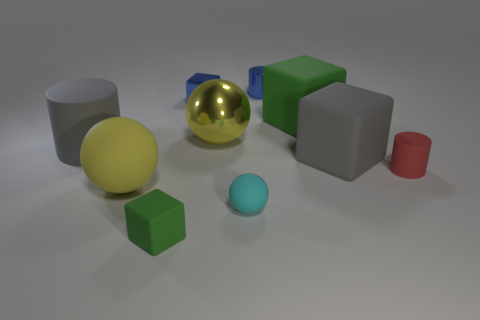How many yellow balls must be subtracted to get 1 yellow balls? 1 Subtract all tiny rubber blocks. How many blocks are left? 3 Subtract all brown cylinders. How many yellow balls are left? 2 Subtract all cyan spheres. How many spheres are left? 2 Subtract 1 cylinders. How many cylinders are left? 2 Subtract all cylinders. How many objects are left? 7 Subtract 0 red spheres. How many objects are left? 10 Subtract all gray cylinders. Subtract all blue blocks. How many cylinders are left? 2 Subtract all blue spheres. Subtract all tiny green cubes. How many objects are left? 9 Add 4 gray blocks. How many gray blocks are left? 5 